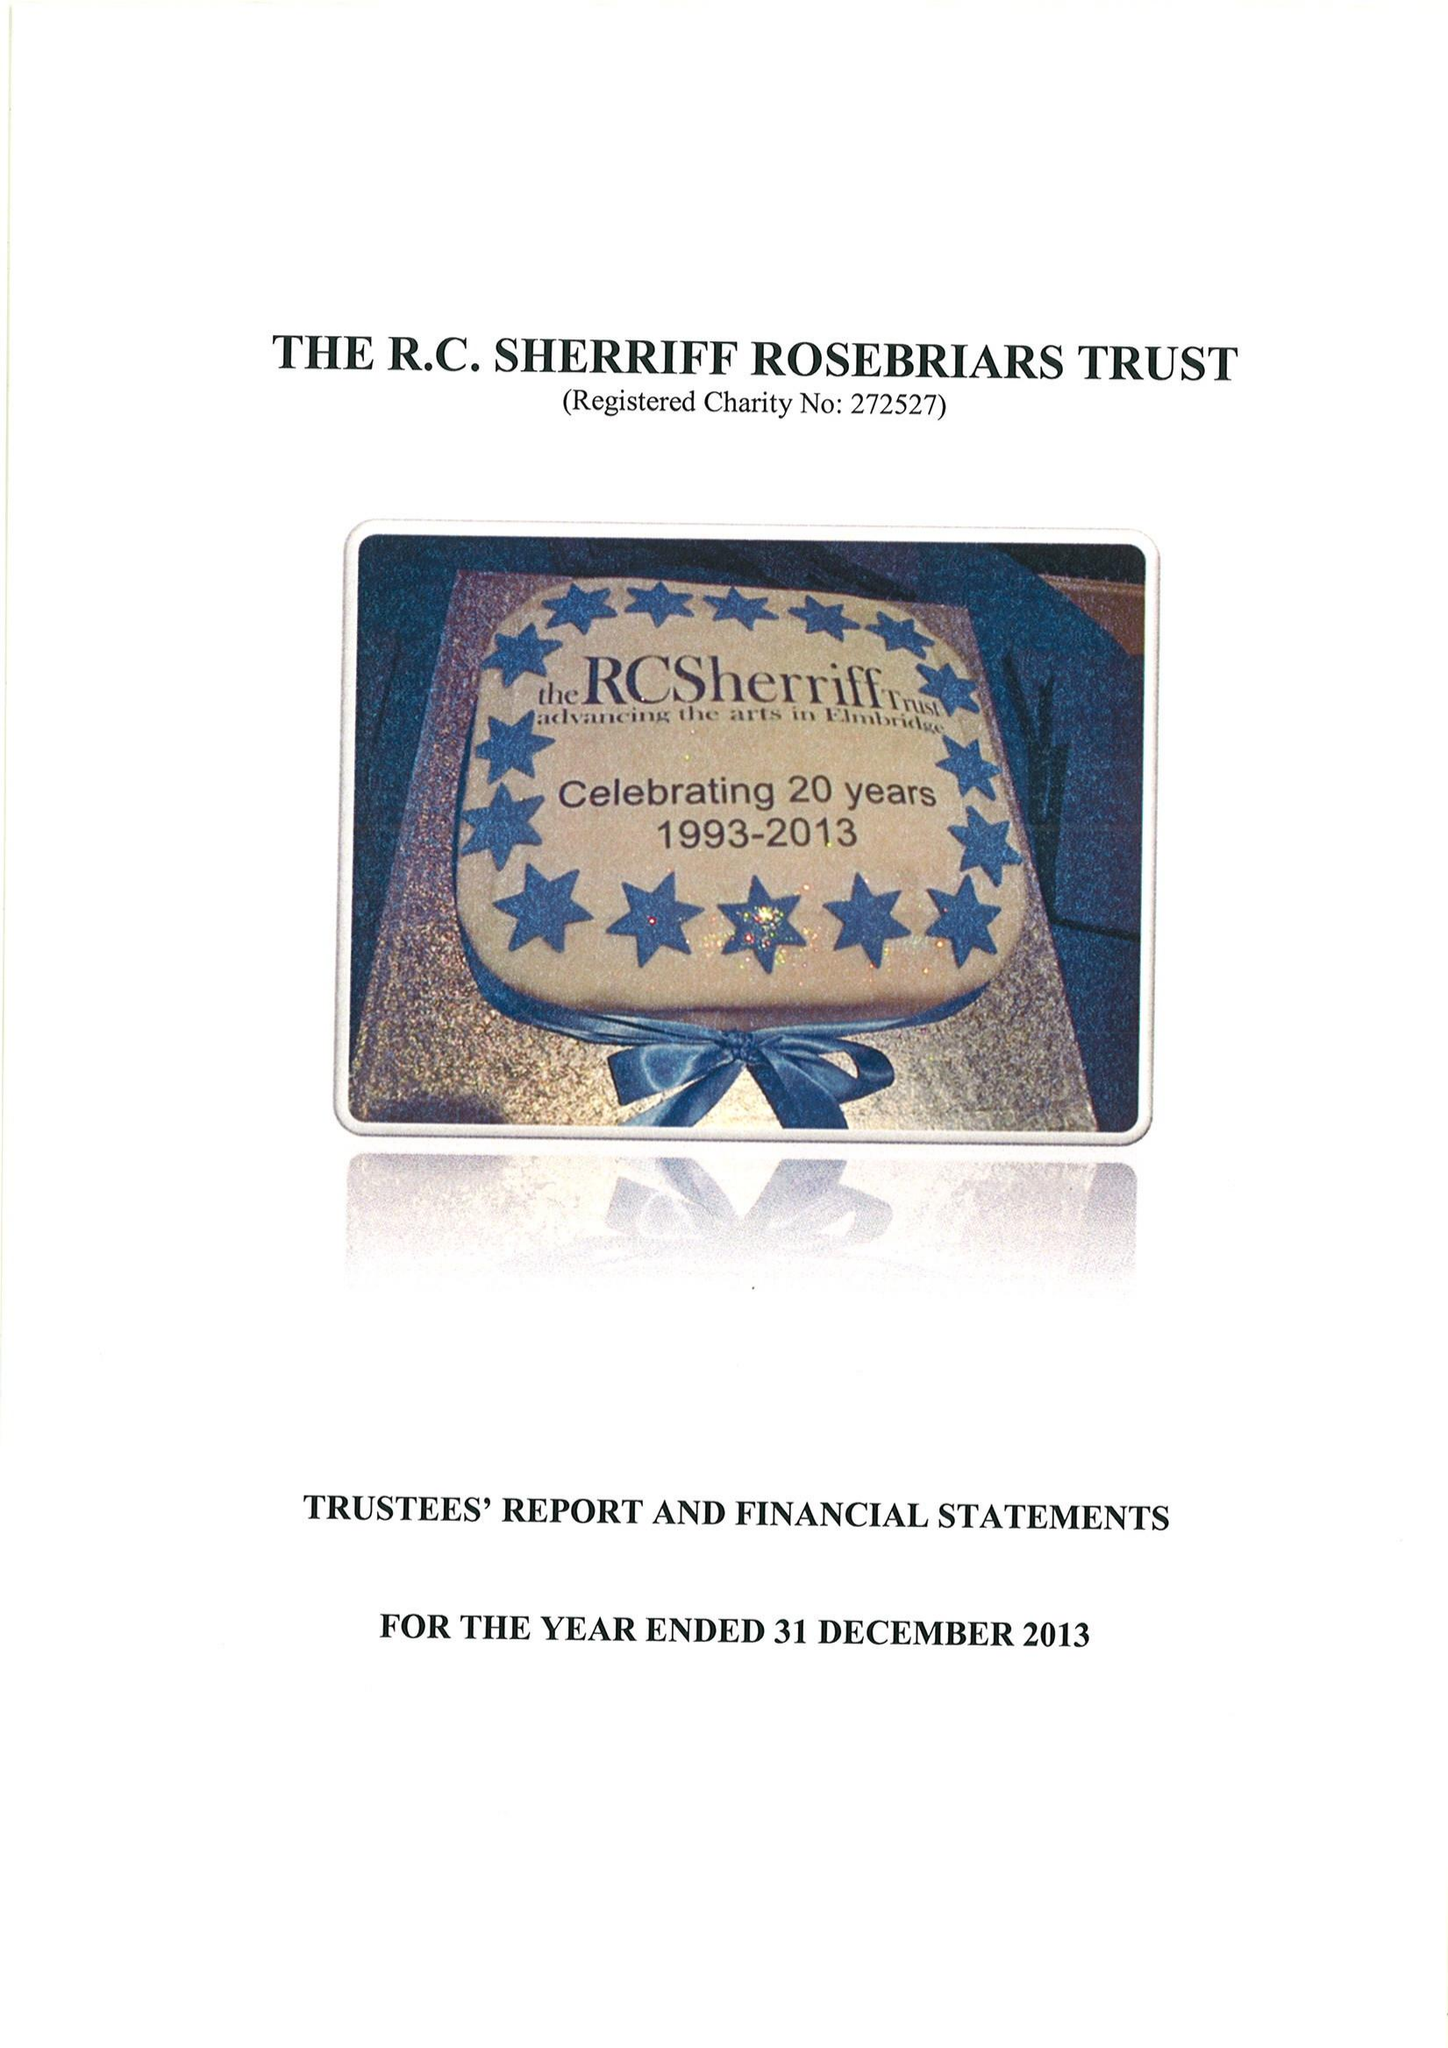What is the value for the charity_name?
Answer the question using a single word or phrase. The Rc Sherriff Rosebriars Trust 